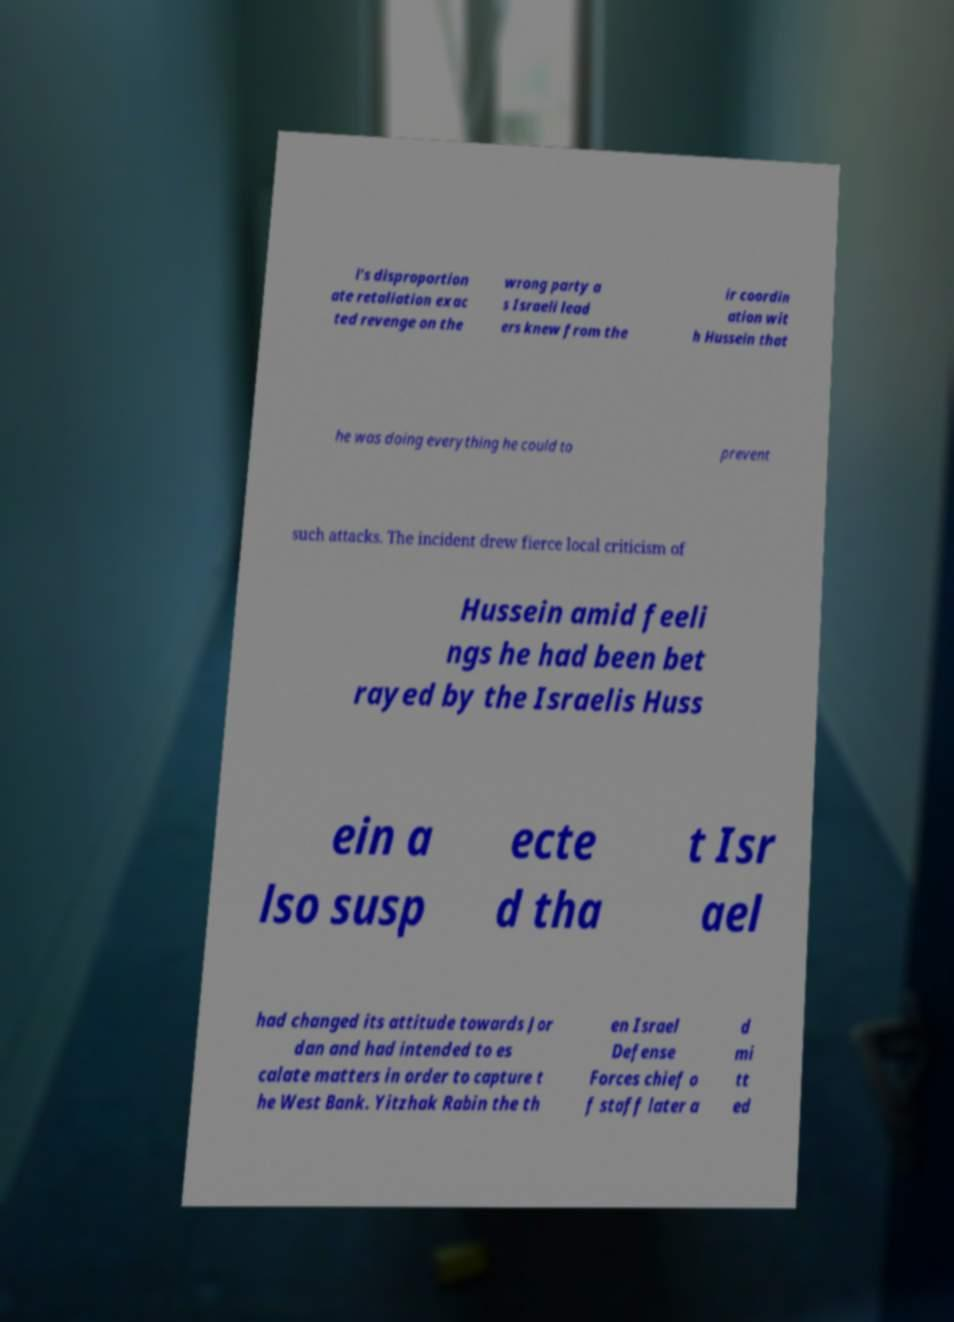Could you extract and type out the text from this image? l's disproportion ate retaliation exac ted revenge on the wrong party a s Israeli lead ers knew from the ir coordin ation wit h Hussein that he was doing everything he could to prevent such attacks. The incident drew fierce local criticism of Hussein amid feeli ngs he had been bet rayed by the Israelis Huss ein a lso susp ecte d tha t Isr ael had changed its attitude towards Jor dan and had intended to es calate matters in order to capture t he West Bank. Yitzhak Rabin the th en Israel Defense Forces chief o f staff later a d mi tt ed 